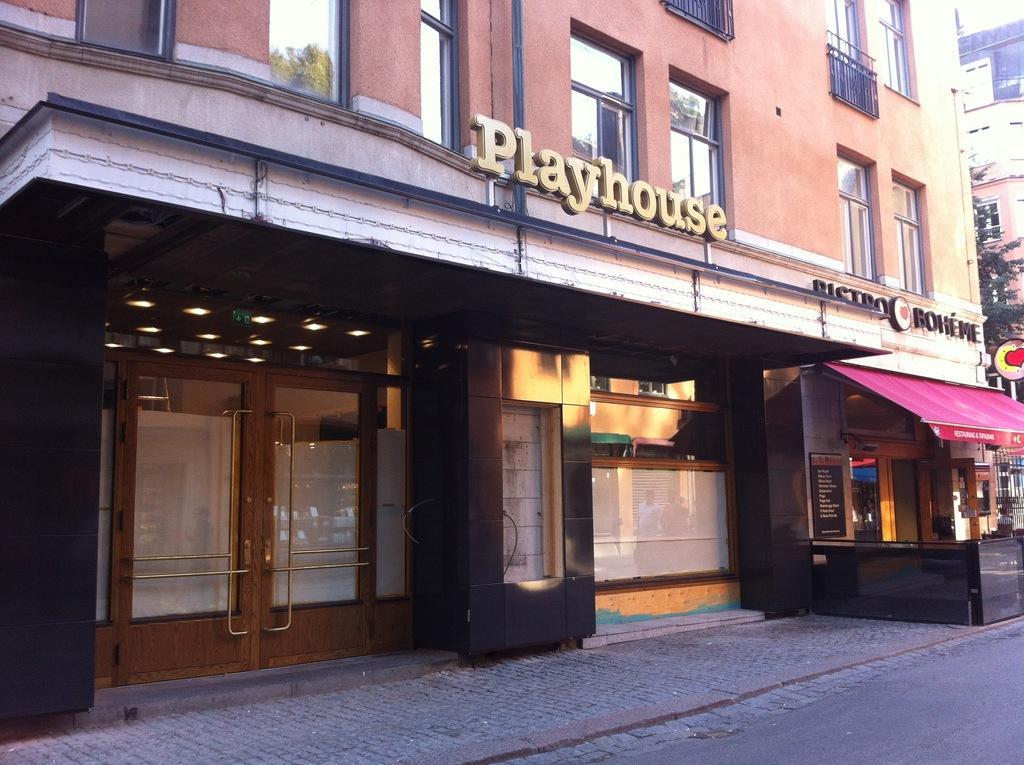How would you summarize this image in a sentence or two? In the image there is a building with walls, glass windows, glass doors and a name board. In front of the building on the footpath there is a store with roof, menu board and some other things. On the right corner of the image there are leaves and also there is a building. 